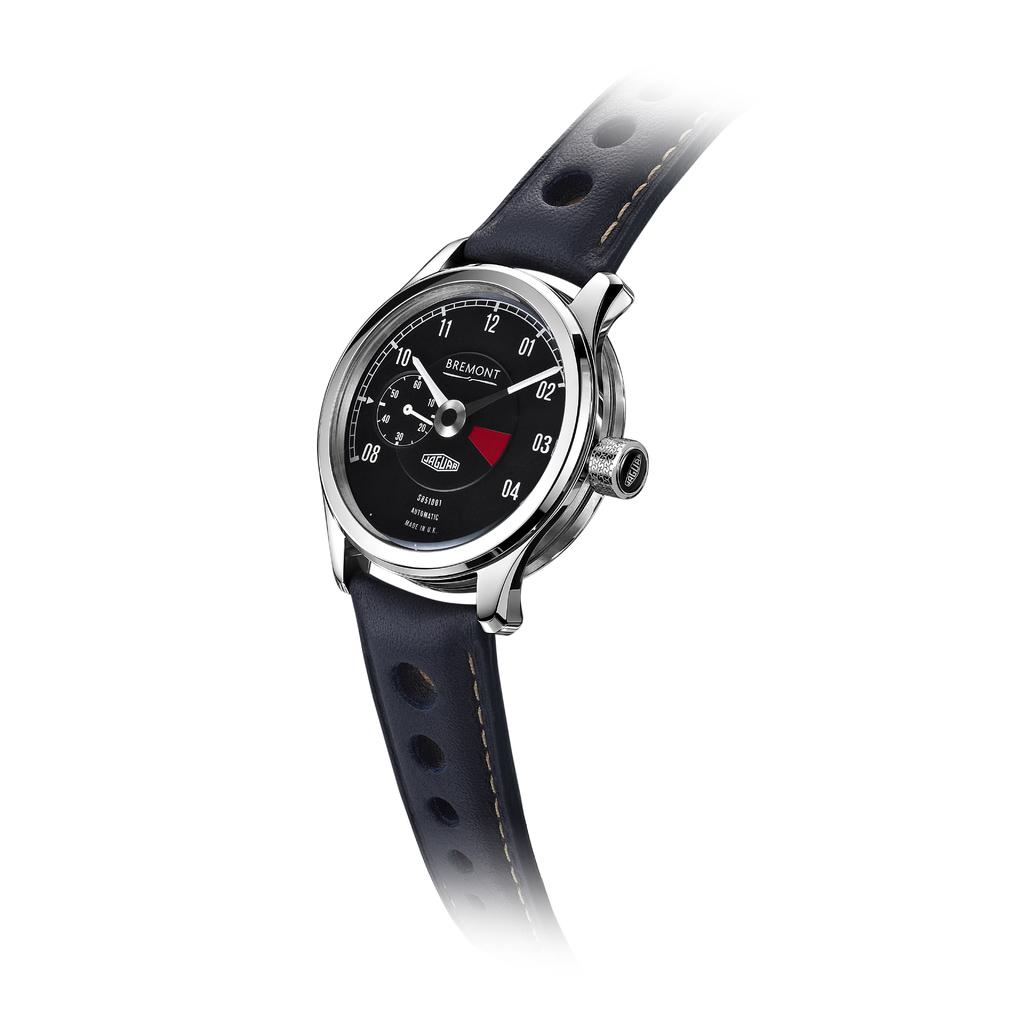What kind of watch is shown?
Provide a succinct answer. Bremont. What time is shown?
Your response must be concise. 10:09. 